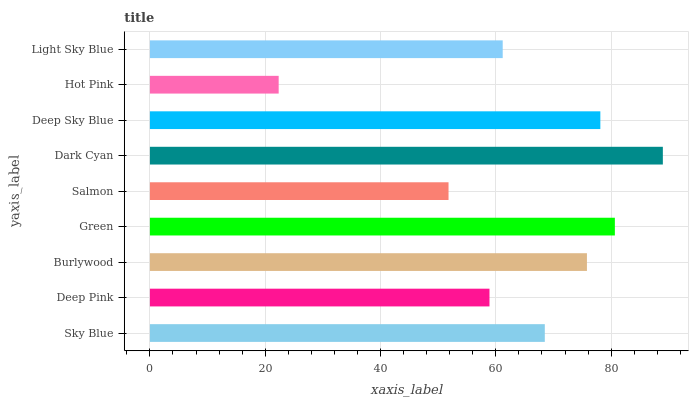Is Hot Pink the minimum?
Answer yes or no. Yes. Is Dark Cyan the maximum?
Answer yes or no. Yes. Is Deep Pink the minimum?
Answer yes or no. No. Is Deep Pink the maximum?
Answer yes or no. No. Is Sky Blue greater than Deep Pink?
Answer yes or no. Yes. Is Deep Pink less than Sky Blue?
Answer yes or no. Yes. Is Deep Pink greater than Sky Blue?
Answer yes or no. No. Is Sky Blue less than Deep Pink?
Answer yes or no. No. Is Sky Blue the high median?
Answer yes or no. Yes. Is Sky Blue the low median?
Answer yes or no. Yes. Is Hot Pink the high median?
Answer yes or no. No. Is Hot Pink the low median?
Answer yes or no. No. 